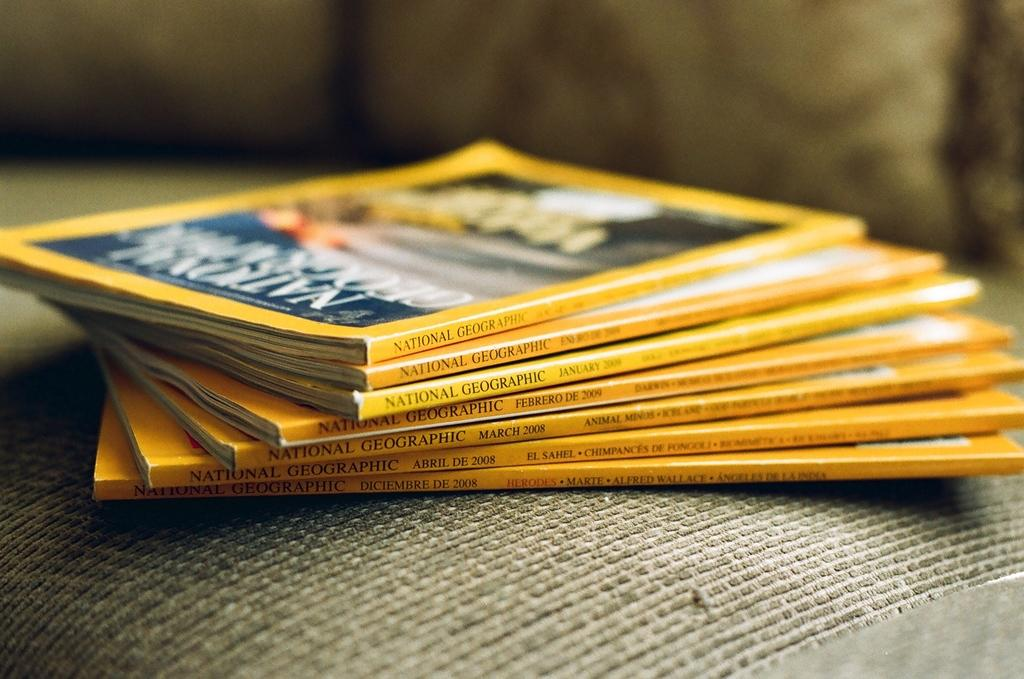Provide a one-sentence caption for the provided image. a stack of National Geographic magazines. 